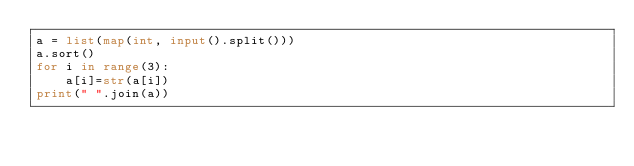<code> <loc_0><loc_0><loc_500><loc_500><_Python_>a = list(map(int, input().split()))
a.sort()
for i in range(3):
    a[i]=str(a[i])
print(" ".join(a))
</code> 